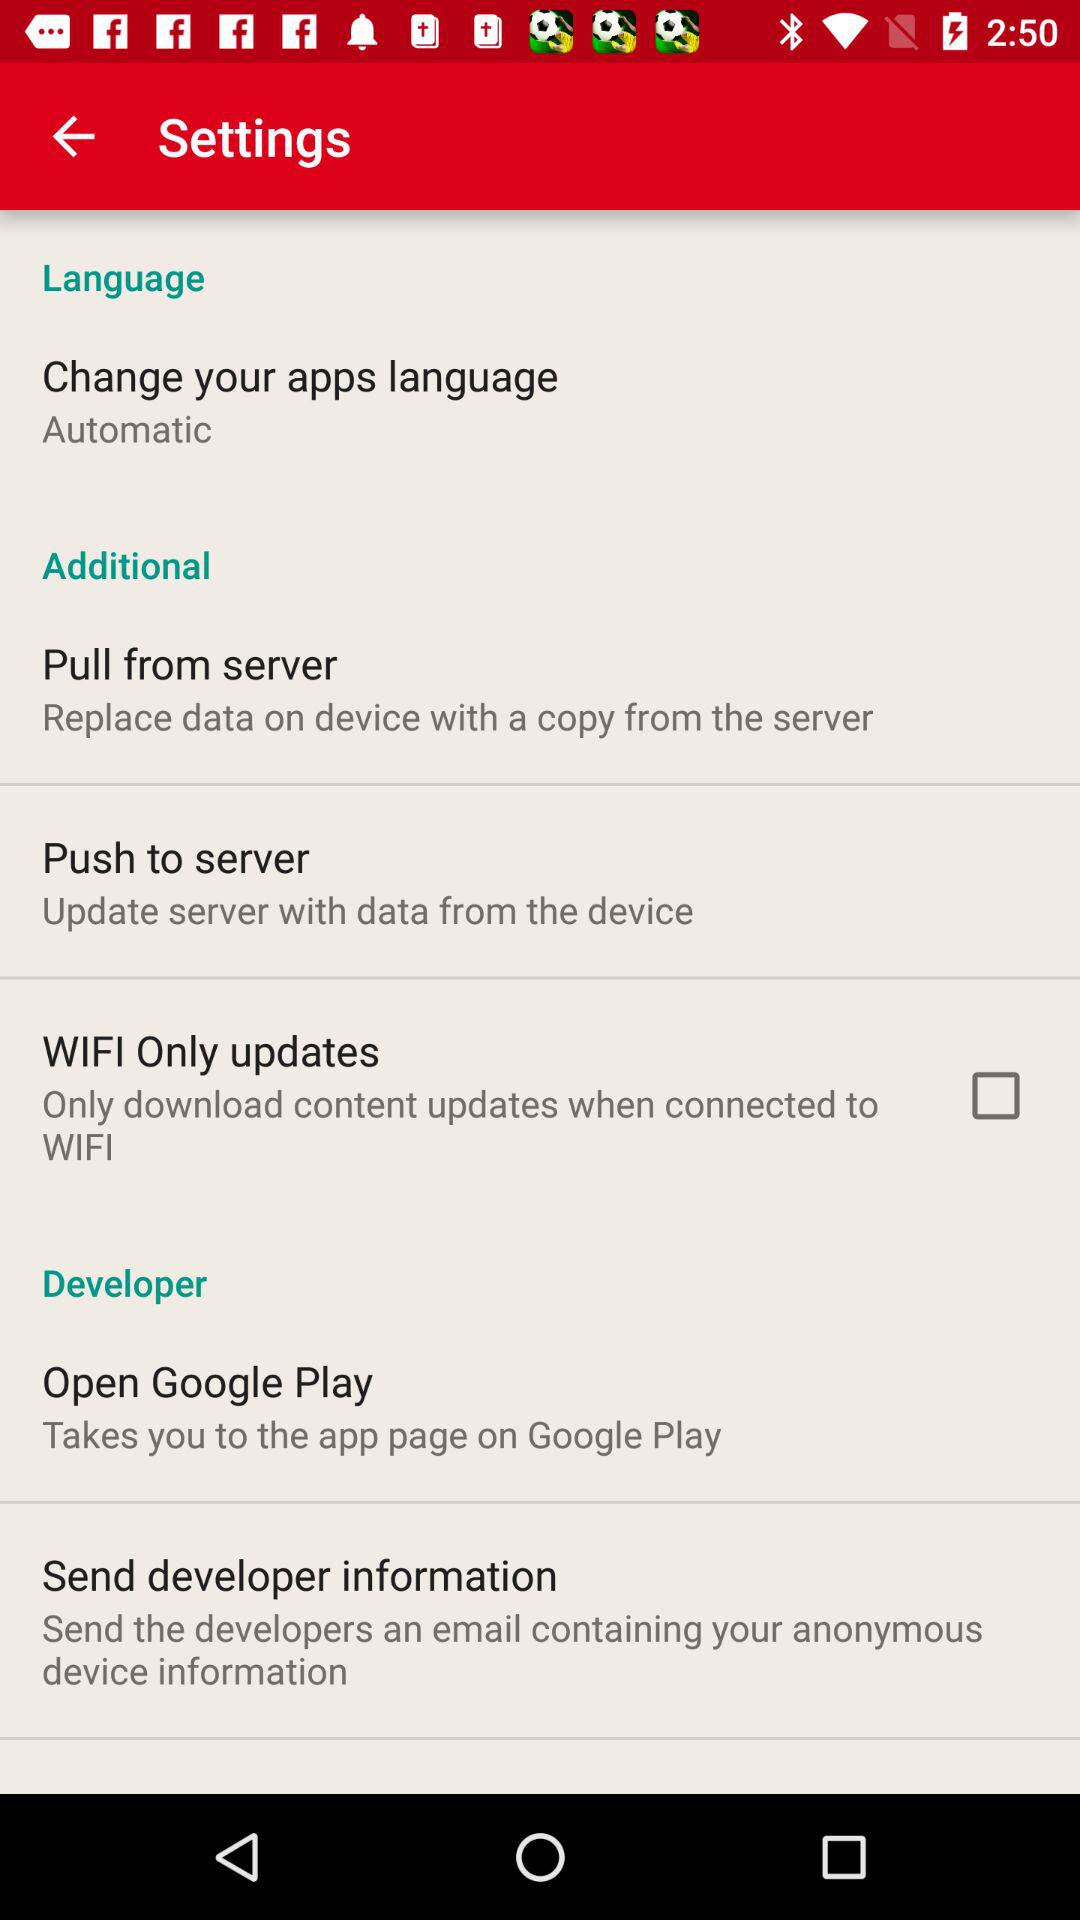What is the description given for the "Push to server" option? The given description is "Update server with data from the device". 